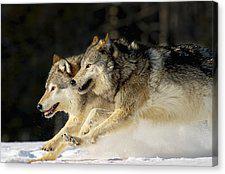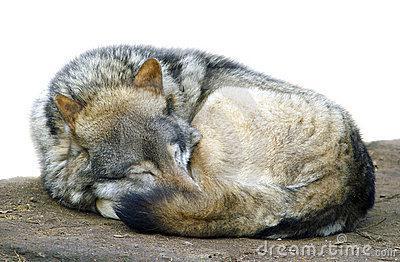The first image is the image on the left, the second image is the image on the right. Evaluate the accuracy of this statement regarding the images: "A single wolf is pictured sleeping in one of the images.". Is it true? Answer yes or no. Yes. 